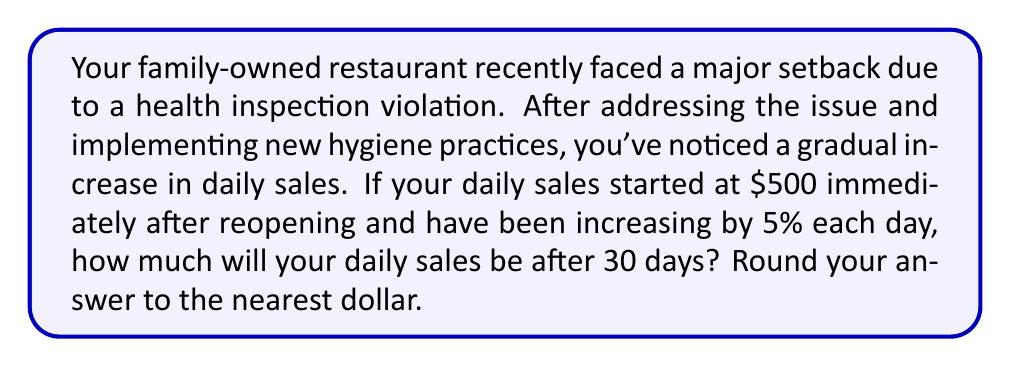Solve this math problem. Let's approach this step-by-step using an exponential growth model:

1) The exponential growth formula is:
   $$A = P(1 + r)^t$$
   Where:
   $A$ = Final amount
   $P$ = Initial principal (starting amount)
   $r$ = Growth rate (as a decimal)
   $t$ = Time period

2) In this case:
   $P = 500$ (initial daily sales)
   $r = 0.05$ (5% growth rate)
   $t = 30$ (days)

3) Plugging these values into the formula:
   $$A = 500(1 + 0.05)^{30}$$

4) Simplify inside the parentheses:
   $$A = 500(1.05)^{30}$$

5) Use a calculator to evaluate $(1.05)^{30}$:
   $$A = 500 \times 4.3219$$

6) Multiply:
   $$A = 2160.95$$

7) Rounding to the nearest dollar:
   $$A \approx 2161$$
Answer: $2161 